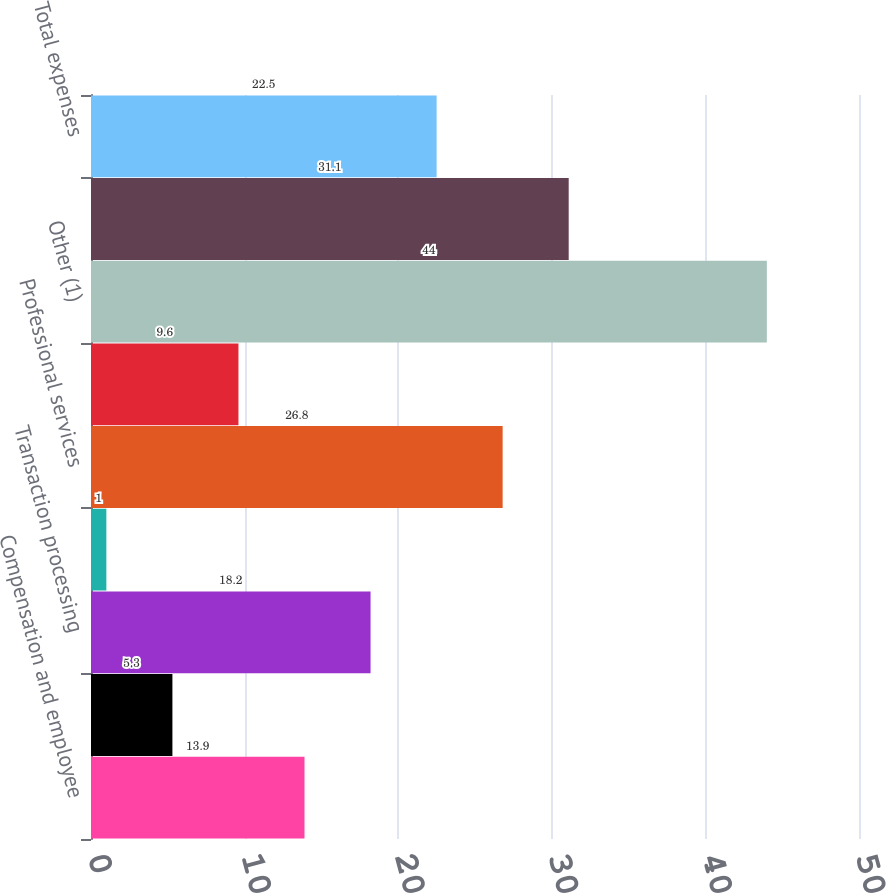Convert chart. <chart><loc_0><loc_0><loc_500><loc_500><bar_chart><fcel>Compensation and employee<fcel>Information systems and<fcel>Transaction processing<fcel>Occupancy<fcel>Professional services<fcel>Amortization of other<fcel>Other (1)<fcel>Total other<fcel>Total expenses<nl><fcel>13.9<fcel>5.3<fcel>18.2<fcel>1<fcel>26.8<fcel>9.6<fcel>44<fcel>31.1<fcel>22.5<nl></chart> 